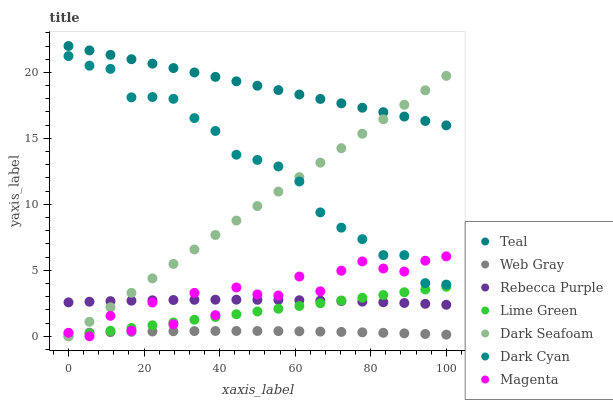Does Web Gray have the minimum area under the curve?
Answer yes or no. Yes. Does Teal have the maximum area under the curve?
Answer yes or no. Yes. Does Dark Seafoam have the minimum area under the curve?
Answer yes or no. No. Does Dark Seafoam have the maximum area under the curve?
Answer yes or no. No. Is Lime Green the smoothest?
Answer yes or no. Yes. Is Magenta the roughest?
Answer yes or no. Yes. Is Dark Seafoam the smoothest?
Answer yes or no. No. Is Dark Seafoam the roughest?
Answer yes or no. No. Does Dark Seafoam have the lowest value?
Answer yes or no. Yes. Does Rebecca Purple have the lowest value?
Answer yes or no. No. Does Teal have the highest value?
Answer yes or no. Yes. Does Dark Seafoam have the highest value?
Answer yes or no. No. Is Rebecca Purple less than Teal?
Answer yes or no. Yes. Is Teal greater than Rebecca Purple?
Answer yes or no. Yes. Does Magenta intersect Lime Green?
Answer yes or no. Yes. Is Magenta less than Lime Green?
Answer yes or no. No. Is Magenta greater than Lime Green?
Answer yes or no. No. Does Rebecca Purple intersect Teal?
Answer yes or no. No. 